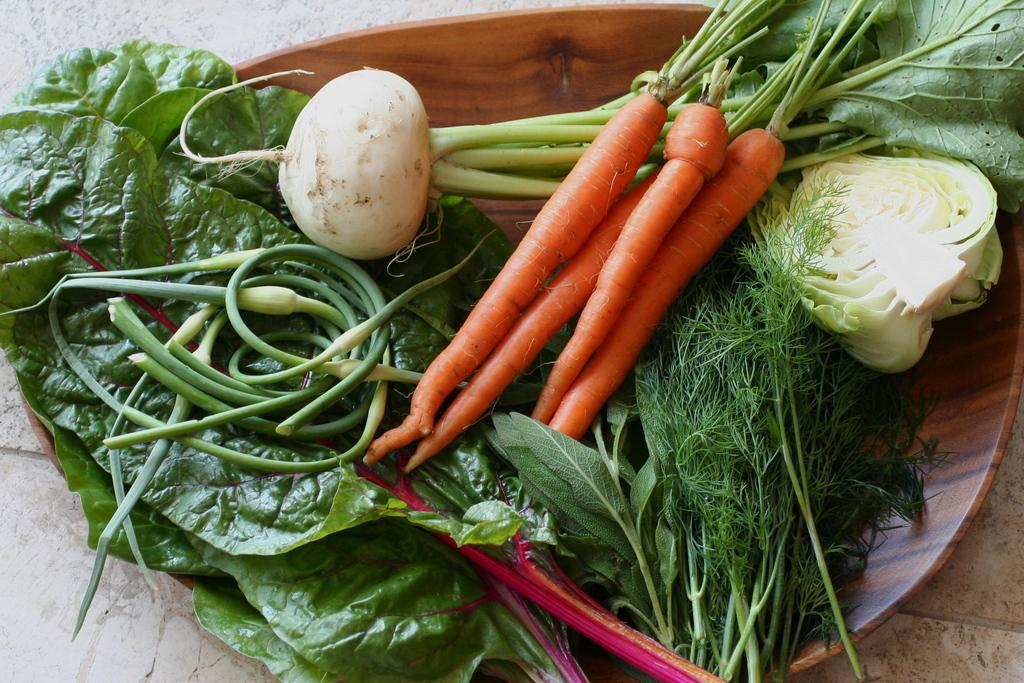What type of vegetables can be seen in the image? There are carrots, cabbage, radishes, spring onions, and leafy vegetables in the image. How are the vegetables arranged in the image? The vegetables are placed on a plate. Where is the plate with the vegetables located? The plate is placed on a surface. What channel is the uncle watching while holding the fog in the image? There is no uncle, channel, or fog present in the image. The image only features vegetables arranged on a plate. 